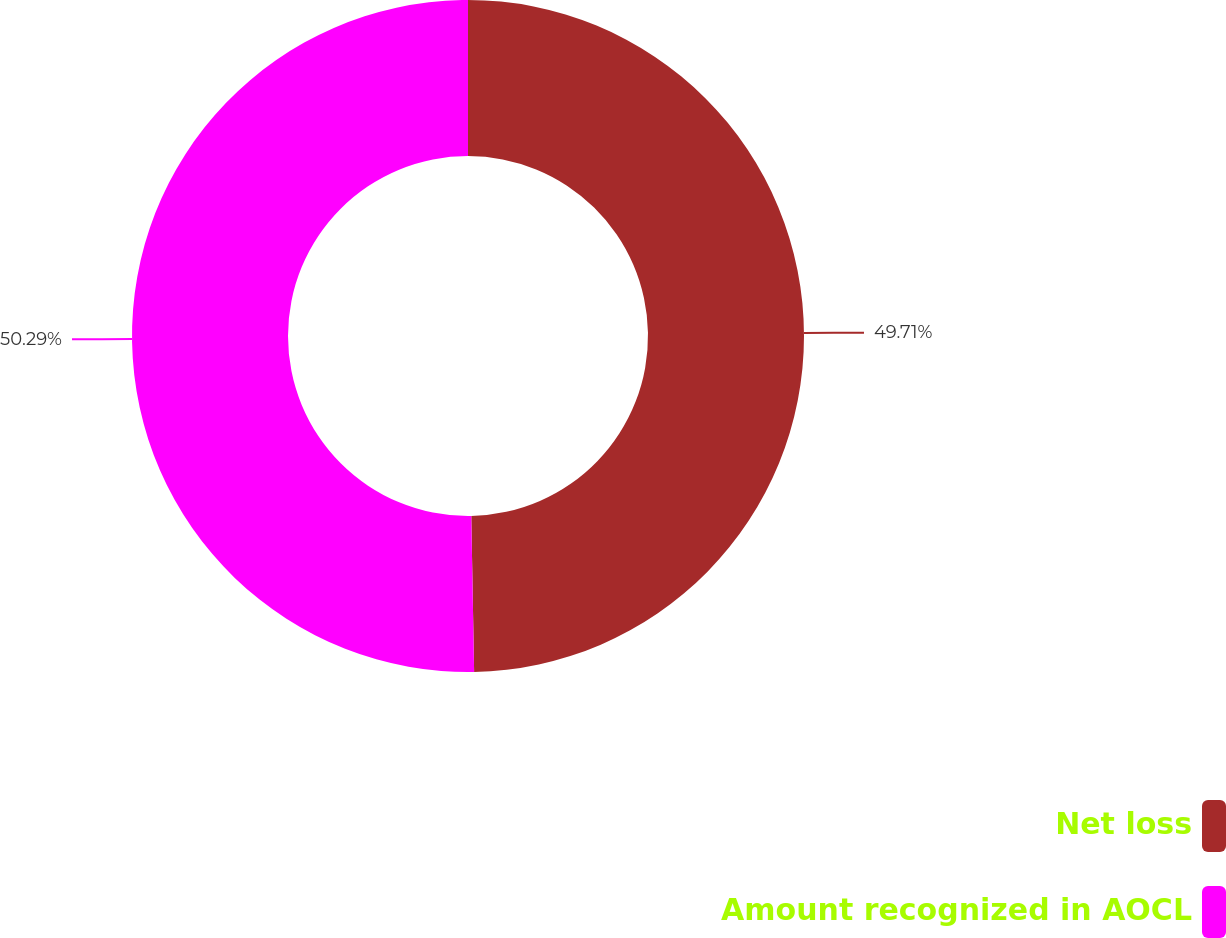Convert chart. <chart><loc_0><loc_0><loc_500><loc_500><pie_chart><fcel>Net loss<fcel>Amount recognized in AOCL<nl><fcel>49.71%<fcel>50.29%<nl></chart> 